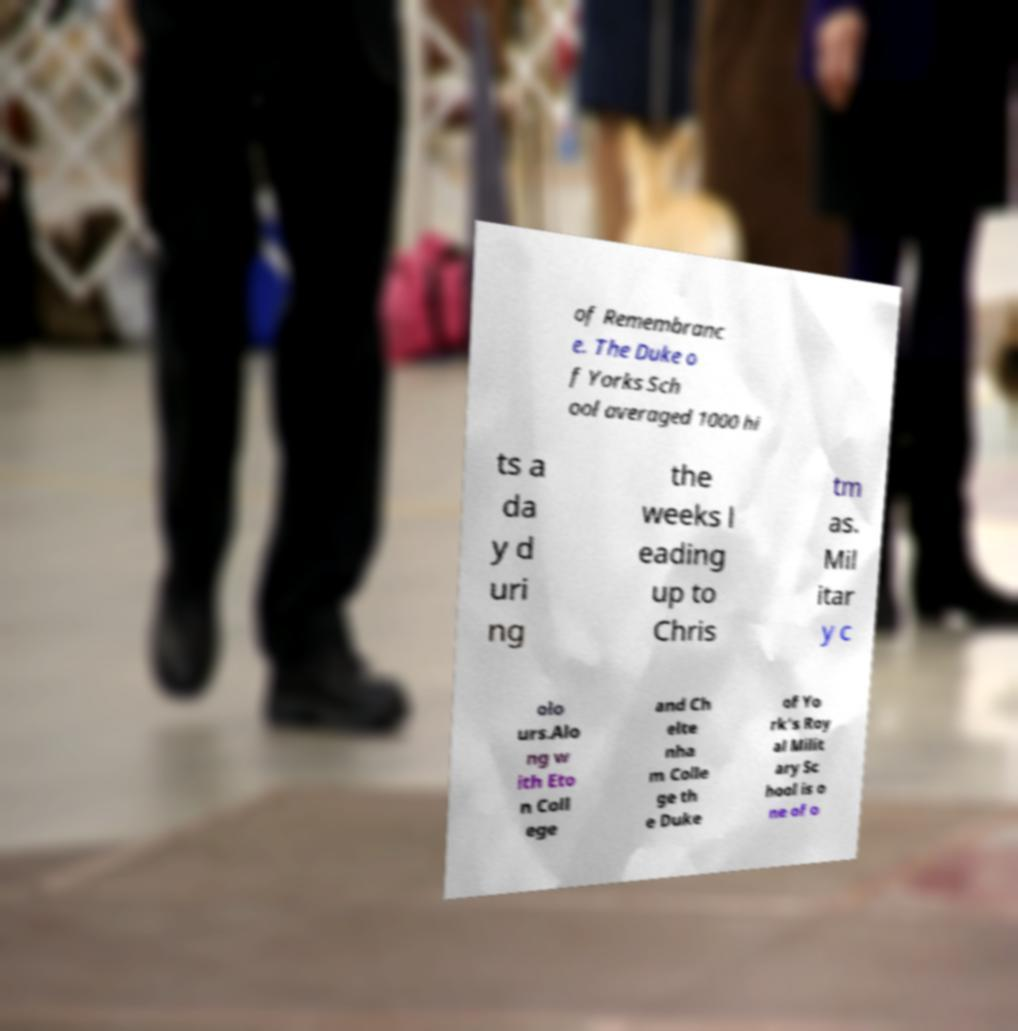Can you read and provide the text displayed in the image?This photo seems to have some interesting text. Can you extract and type it out for me? of Remembranc e. The Duke o f Yorks Sch ool averaged 1000 hi ts a da y d uri ng the weeks l eading up to Chris tm as. Mil itar y c olo urs.Alo ng w ith Eto n Coll ege and Ch elte nha m Colle ge th e Duke of Yo rk's Roy al Milit ary Sc hool is o ne of o 